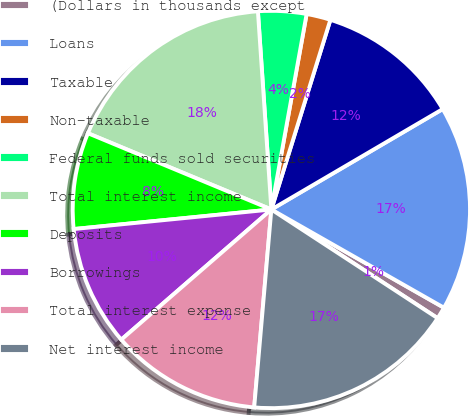Convert chart to OTSL. <chart><loc_0><loc_0><loc_500><loc_500><pie_chart><fcel>(Dollars in thousands except<fcel>Loans<fcel>Taxable<fcel>Non-taxable<fcel>Federal funds sold securities<fcel>Total interest income<fcel>Deposits<fcel>Borrowings<fcel>Total interest expense<fcel>Net interest income<nl><fcel>0.98%<fcel>16.67%<fcel>11.76%<fcel>1.96%<fcel>3.92%<fcel>17.65%<fcel>7.84%<fcel>9.8%<fcel>12.25%<fcel>17.16%<nl></chart> 